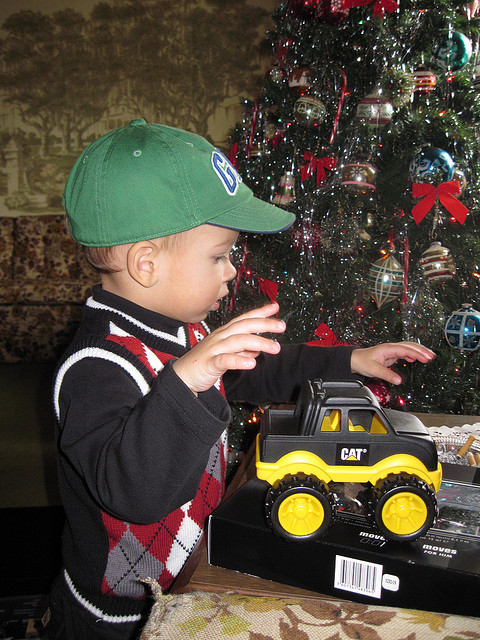Please transcribe the text in this image. C CAT MOVER MOVE 